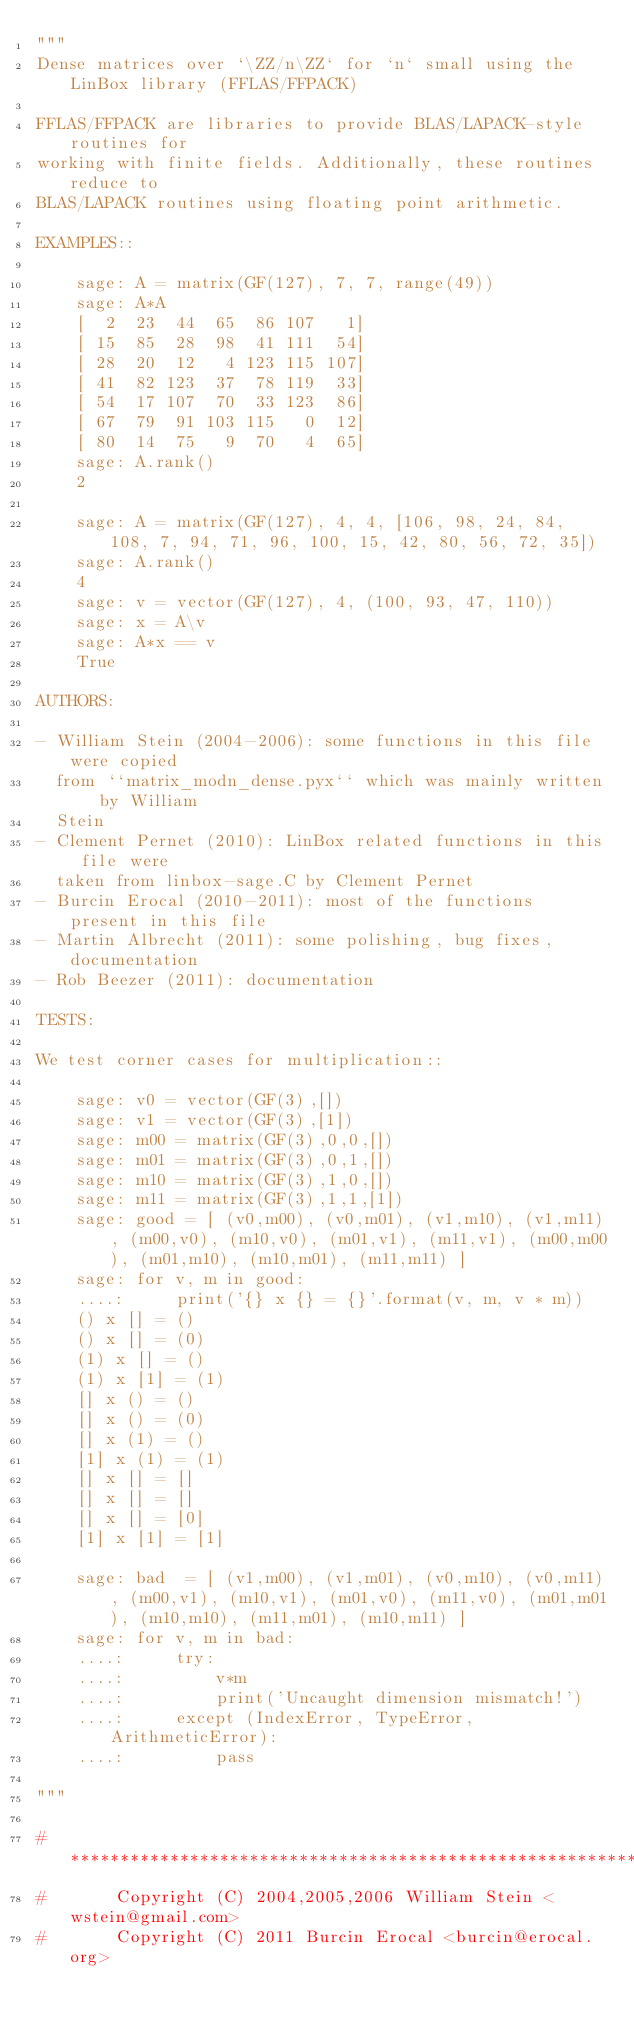Convert code to text. <code><loc_0><loc_0><loc_500><loc_500><_Cython_>"""
Dense matrices over `\ZZ/n\ZZ` for `n` small using the LinBox library (FFLAS/FFPACK)

FFLAS/FFPACK are libraries to provide BLAS/LAPACK-style routines for
working with finite fields. Additionally, these routines reduce to
BLAS/LAPACK routines using floating point arithmetic.

EXAMPLES::

    sage: A = matrix(GF(127), 7, 7, range(49))
    sage: A*A
    [  2  23  44  65  86 107   1]
    [ 15  85  28  98  41 111  54]
    [ 28  20  12   4 123 115 107]
    [ 41  82 123  37  78 119  33]
    [ 54  17 107  70  33 123  86]
    [ 67  79  91 103 115   0  12]
    [ 80  14  75   9  70   4  65]
    sage: A.rank()
    2

    sage: A = matrix(GF(127), 4, 4, [106, 98, 24, 84, 108, 7, 94, 71, 96, 100, 15, 42, 80, 56, 72, 35])
    sage: A.rank()
    4
    sage: v = vector(GF(127), 4, (100, 93, 47, 110))
    sage: x = A\v
    sage: A*x == v
    True

AUTHORS:

- William Stein (2004-2006): some functions in this file were copied
  from ``matrix_modn_dense.pyx`` which was mainly written by William
  Stein
- Clement Pernet (2010): LinBox related functions in this file were
  taken from linbox-sage.C by Clement Pernet
- Burcin Erocal (2010-2011): most of the functions present in this file
- Martin Albrecht (2011): some polishing, bug fixes, documentation
- Rob Beezer (2011): documentation

TESTS:

We test corner cases for multiplication::

    sage: v0 = vector(GF(3),[])
    sage: v1 = vector(GF(3),[1])
    sage: m00 = matrix(GF(3),0,0,[])
    sage: m01 = matrix(GF(3),0,1,[])
    sage: m10 = matrix(GF(3),1,0,[])
    sage: m11 = matrix(GF(3),1,1,[1])
    sage: good = [ (v0,m00), (v0,m01), (v1,m10), (v1,m11), (m00,v0), (m10,v0), (m01,v1), (m11,v1), (m00,m00), (m01,m10), (m10,m01), (m11,m11) ]
    sage: for v, m in good:
    ....:     print('{} x {} = {}'.format(v, m, v * m))
    () x [] = ()
    () x [] = (0)
    (1) x [] = ()
    (1) x [1] = (1)
    [] x () = ()
    [] x () = (0)
    [] x (1) = ()
    [1] x (1) = (1)
    [] x [] = []
    [] x [] = []
    [] x [] = [0]
    [1] x [1] = [1]

    sage: bad  = [ (v1,m00), (v1,m01), (v0,m10), (v0,m11), (m00,v1), (m10,v1), (m01,v0), (m11,v0), (m01,m01), (m10,m10), (m11,m01), (m10,m11) ]
    sage: for v, m in bad:
    ....:     try:
    ....:         v*m
    ....:         print('Uncaught dimension mismatch!')
    ....:     except (IndexError, TypeError, ArithmeticError):
    ....:         pass

"""

#*****************************************************************************
#       Copyright (C) 2004,2005,2006 William Stein <wstein@gmail.com>
#       Copyright (C) 2011 Burcin Erocal <burcin@erocal.org></code> 